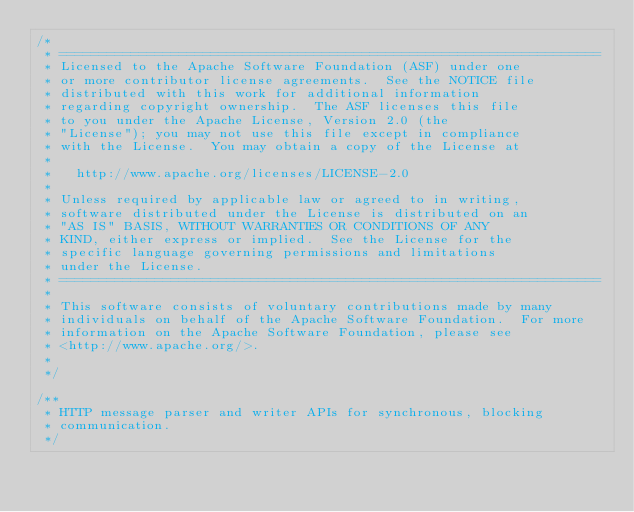<code> <loc_0><loc_0><loc_500><loc_500><_Java_>/*
 * ====================================================================
 * Licensed to the Apache Software Foundation (ASF) under one
 * or more contributor license agreements.  See the NOTICE file
 * distributed with this work for additional information
 * regarding copyright ownership.  The ASF licenses this file
 * to you under the Apache License, Version 2.0 (the
 * "License"); you may not use this file except in compliance
 * with the License.  You may obtain a copy of the License at
 *
 *   http://www.apache.org/licenses/LICENSE-2.0
 *
 * Unless required by applicable law or agreed to in writing,
 * software distributed under the License is distributed on an
 * "AS IS" BASIS, WITHOUT WARRANTIES OR CONDITIONS OF ANY
 * KIND, either express or implied.  See the License for the
 * specific language governing permissions and limitations
 * under the License.
 * ====================================================================
 *
 * This software consists of voluntary contributions made by many
 * individuals on behalf of the Apache Software Foundation.  For more
 * information on the Apache Software Foundation, please see
 * <http://www.apache.org/>.
 *
 */

/**
 * HTTP message parser and writer APIs for synchronous, blocking
 * communication.
 */</code> 